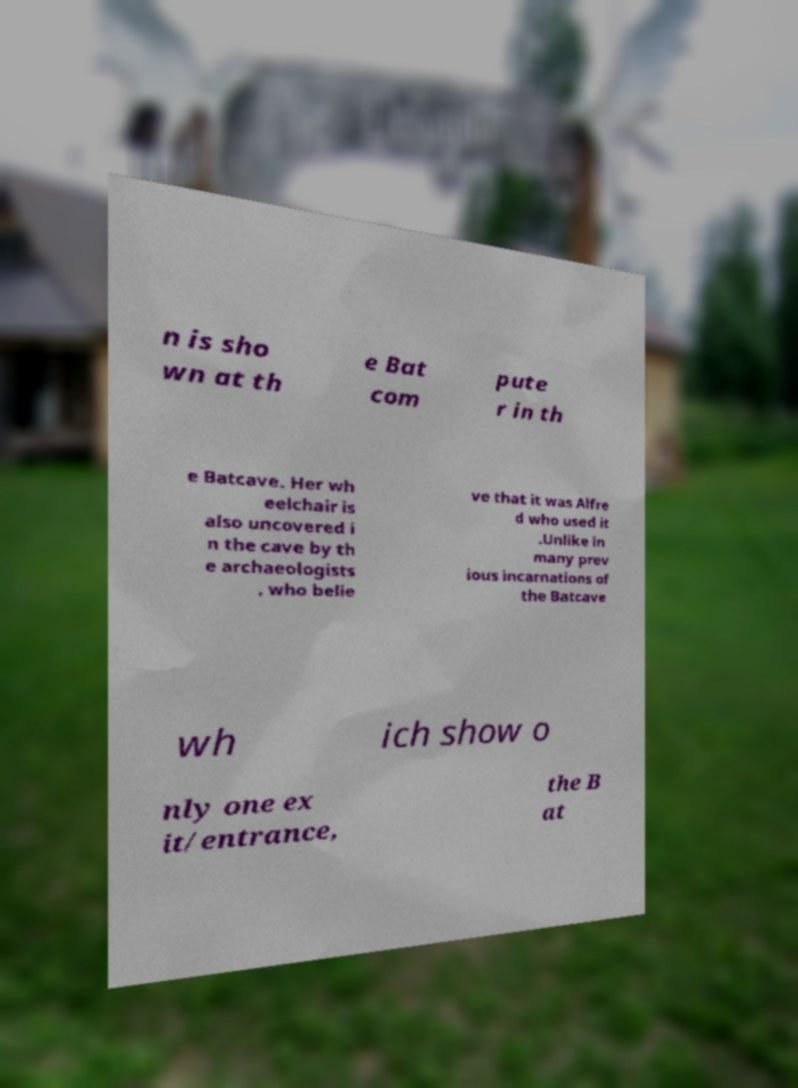Please read and relay the text visible in this image. What does it say? n is sho wn at th e Bat com pute r in th e Batcave. Her wh eelchair is also uncovered i n the cave by th e archaeologists , who belie ve that it was Alfre d who used it .Unlike in many prev ious incarnations of the Batcave wh ich show o nly one ex it/entrance, the B at 